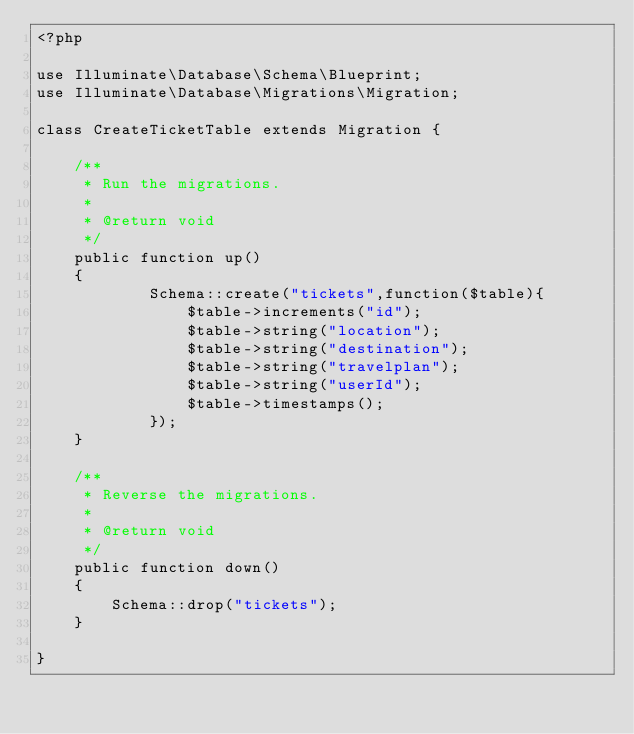Convert code to text. <code><loc_0><loc_0><loc_500><loc_500><_PHP_><?php

use Illuminate\Database\Schema\Blueprint;
use Illuminate\Database\Migrations\Migration;

class CreateTicketTable extends Migration {

	/**
	 * Run the migrations.
	 *
	 * @return void
	 */
	public function up()
	{
			Schema::create("tickets",function($table){
				$table->increments("id");
				$table->string("location");
				$table->string("destination");
				$table->string("travelplan");
				$table->string("userId");
				$table->timestamps();
			});
	}

	/**
	 * Reverse the migrations.
	 *
	 * @return void
	 */
	public function down()
	{
		Schema::drop("tickets");
	}

}
</code> 